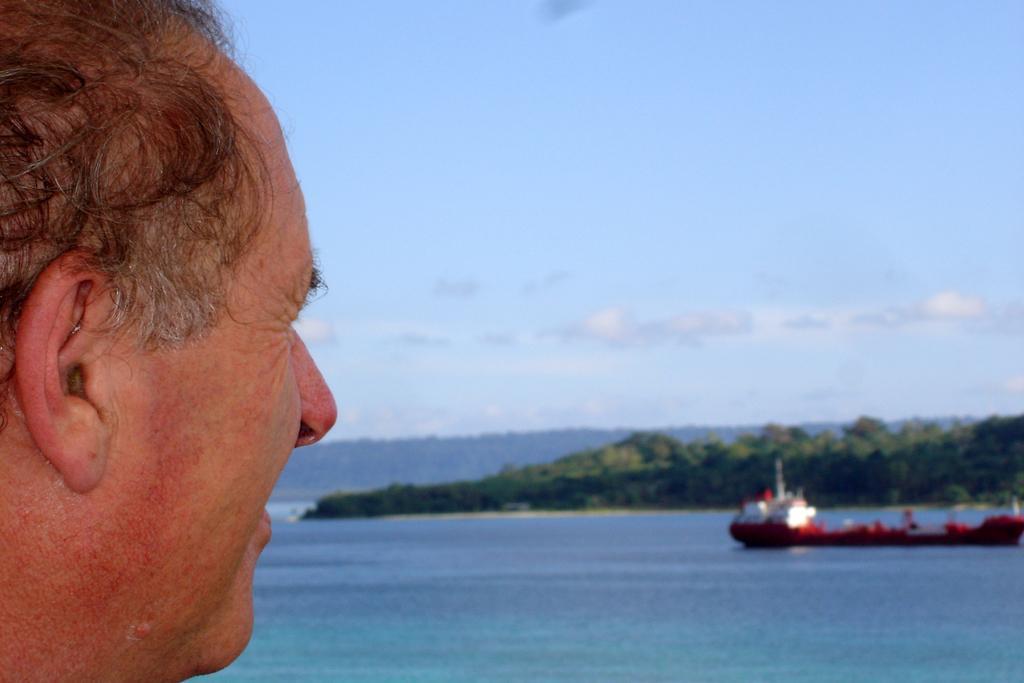Can you describe this image briefly? In this picture I can see a person face, in front I can see a boat on the water surface, behind I can see the hills. 